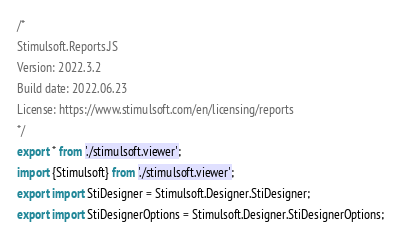Convert code to text. <code><loc_0><loc_0><loc_500><loc_500><_TypeScript_>/*
Stimulsoft.Reports.JS
Version: 2022.3.2
Build date: 2022.06.23
License: https://www.stimulsoft.com/en/licensing/reports
*/
export * from './stimulsoft.viewer';
import {Stimulsoft} from './stimulsoft.viewer';
export import StiDesigner = Stimulsoft.Designer.StiDesigner;
export import StiDesignerOptions = Stimulsoft.Designer.StiDesignerOptions;</code> 